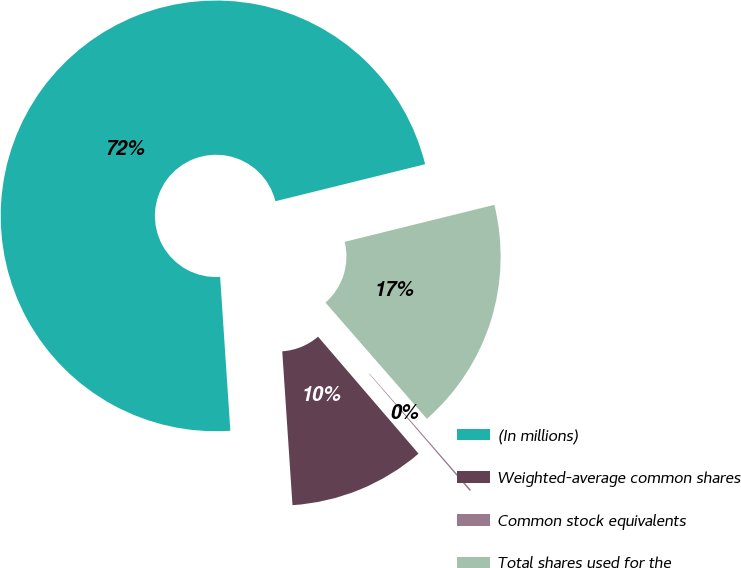Convert chart to OTSL. <chart><loc_0><loc_0><loc_500><loc_500><pie_chart><fcel>(In millions)<fcel>Weighted-average common shares<fcel>Common stock equivalents<fcel>Total shares used for the<nl><fcel>72.2%<fcel>10.24%<fcel>0.12%<fcel>17.44%<nl></chart> 